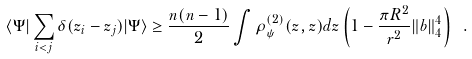Convert formula to latex. <formula><loc_0><loc_0><loc_500><loc_500>\langle \Psi | \sum _ { i < j } \delta ( z _ { i } - z _ { j } ) | \Psi \rangle \geq \frac { n ( n - 1 ) } { 2 } \int \rho _ { \psi } ^ { ( 2 ) } ( z , z ) d z \left ( 1 - \frac { \pi R ^ { 2 } } { r ^ { 2 } } \| b \| _ { 4 } ^ { 4 } \right ) \ .</formula> 